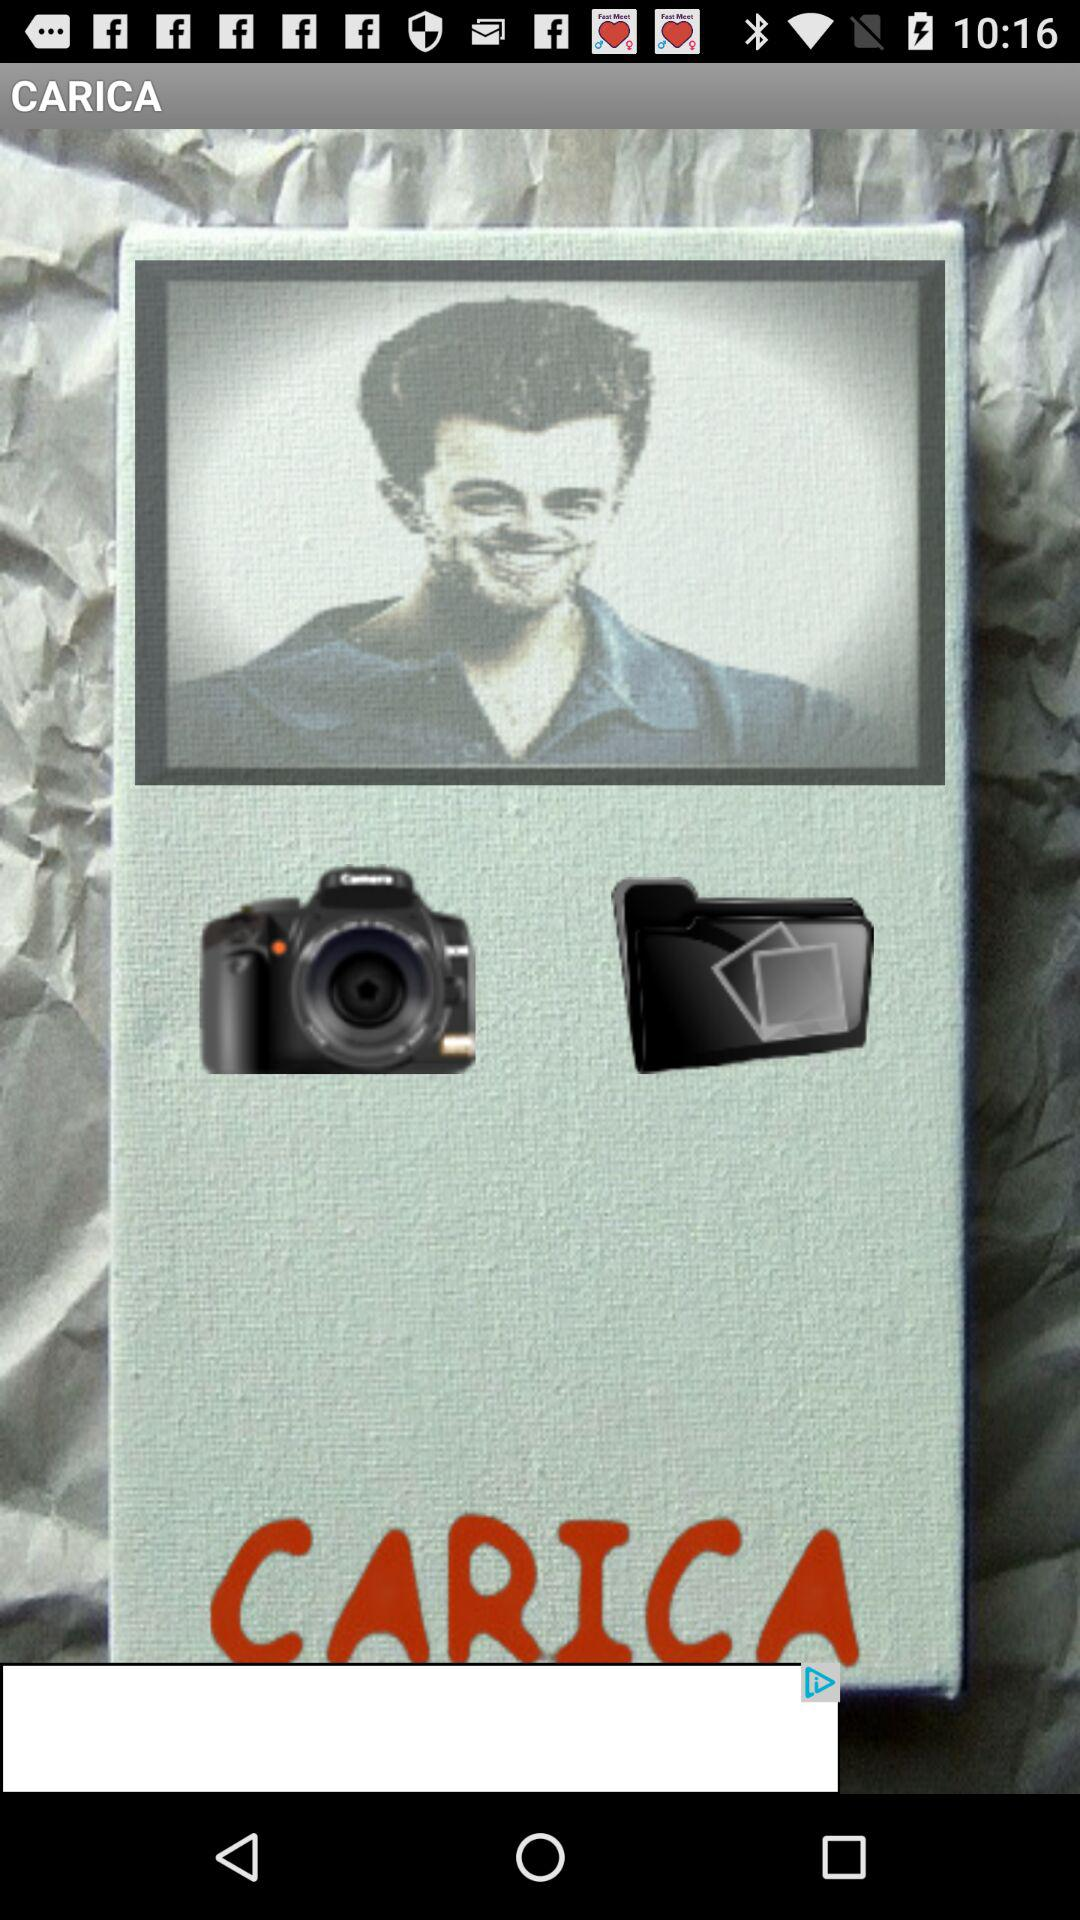What is the application name? The application name is "CARICA". 